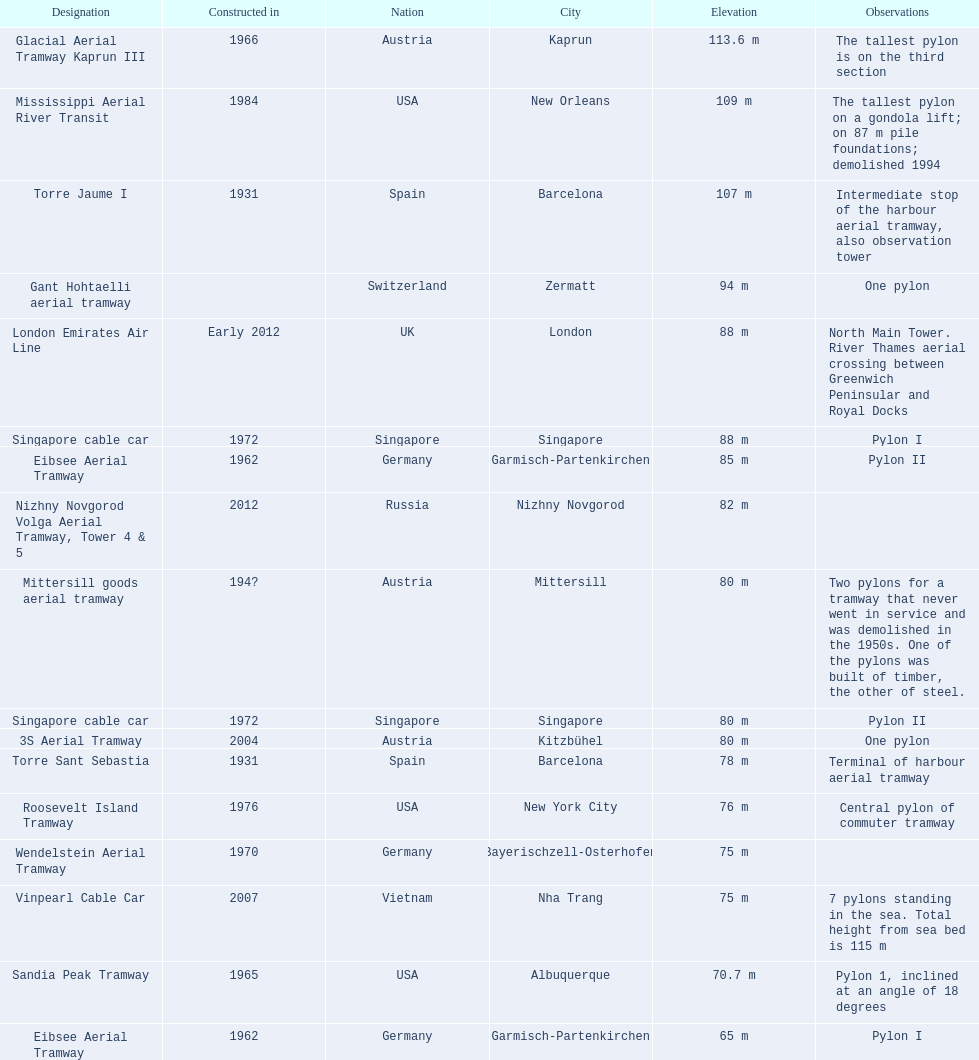Which aerial lifts are over 100 meters tall? Glacial Aerial Tramway Kaprun III, Mississippi Aerial River Transit, Torre Jaume I. Which of those was built last? Mississippi Aerial River Transit. And what is its total height? 109 m. 